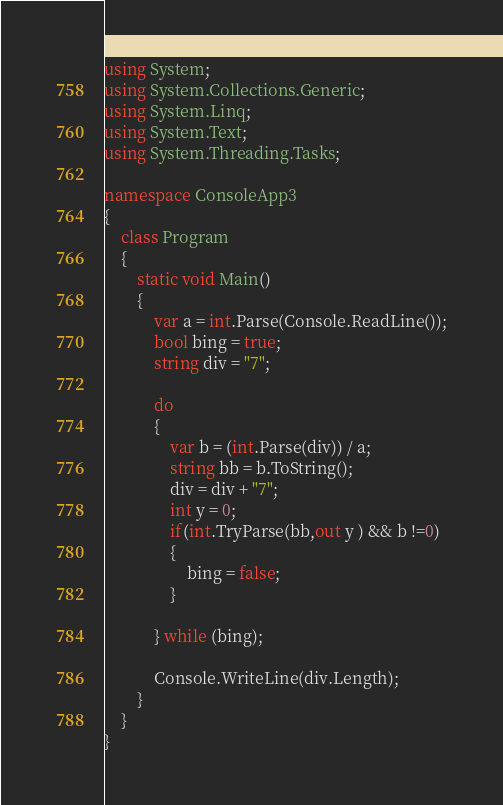<code> <loc_0><loc_0><loc_500><loc_500><_C#_>using System;
using System.Collections.Generic;
using System.Linq;
using System.Text;
using System.Threading.Tasks;

namespace ConsoleApp3
{
    class Program
    {
        static void Main()
        {
            var a = int.Parse(Console.ReadLine());
            bool bing = true;
            string div = "7";

            do
            {
                var b = (int.Parse(div)) / a;
                string bb = b.ToString();
                div = div + "7";
                int y = 0;
                if(int.TryParse(bb,out y ) && b !=0)
                {
                    bing = false;
                }

            } while (bing);

            Console.WriteLine(div.Length);
        }
    }
}
</code> 